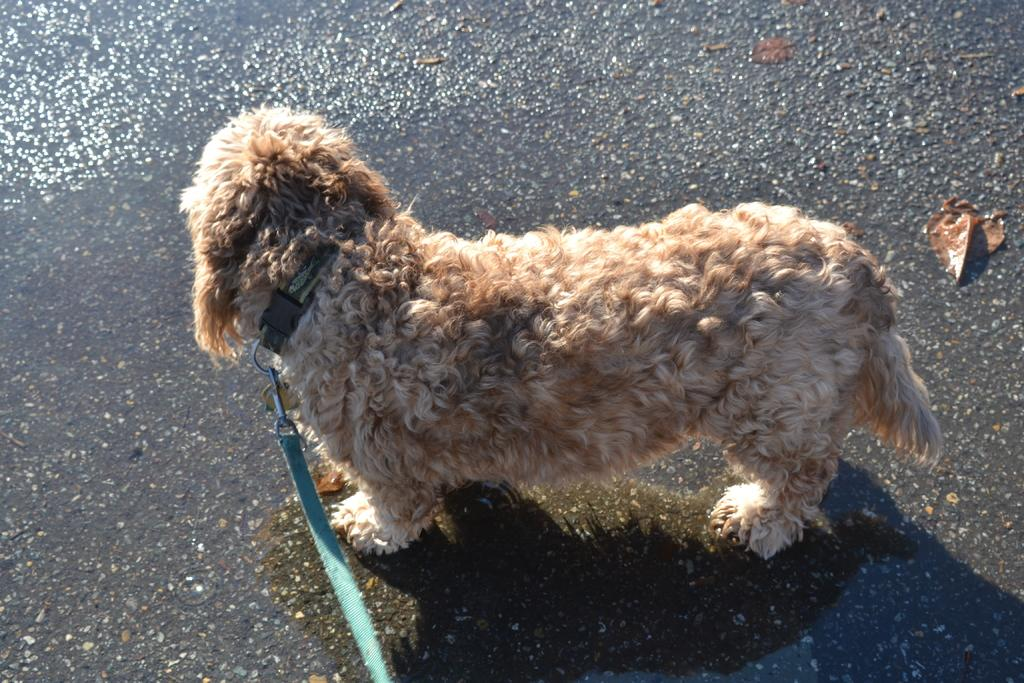What type of animal is in the image? There is a dog in the image. How is the dog being controlled or guided in the image? The dog has a leash. What is the position of the leash in the image? The leash is on the ground. How many passengers are riding in the cart in the image? There is no cart present in the image; it features a dog with a leash on the ground. What type of coil is wrapped around the dog's body in the image? There is no coil present in the image; it features a dog with a leash on the ground. 